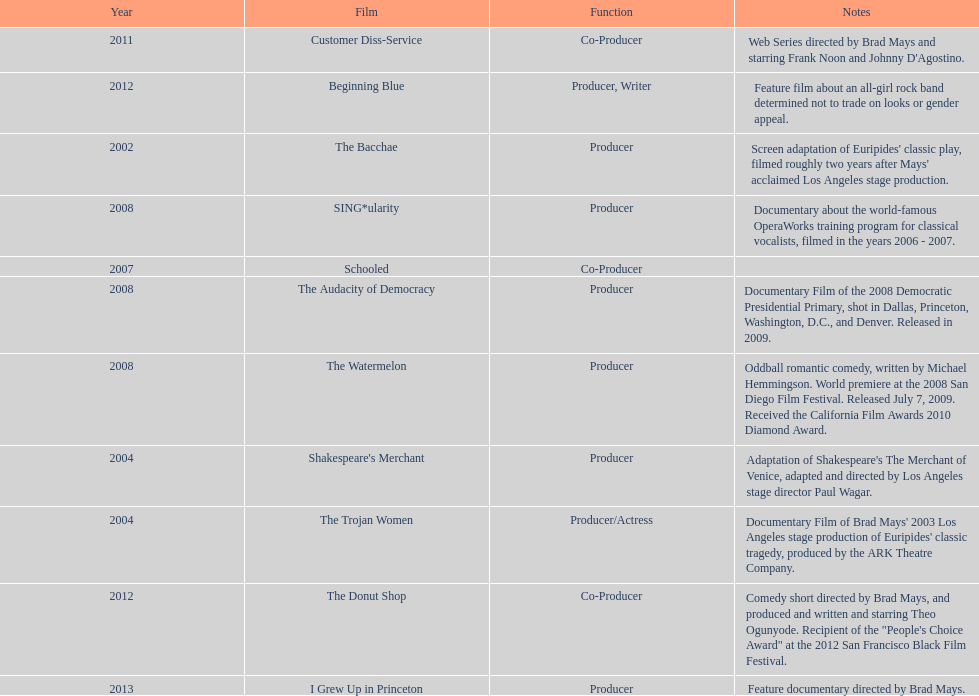Help me parse the entirety of this table. {'header': ['Year', 'Film', 'Function', 'Notes'], 'rows': [['2011', 'Customer Diss-Service', 'Co-Producer', "Web Series directed by Brad Mays and starring Frank Noon and Johnny D'Agostino."], ['2012', 'Beginning Blue', 'Producer, Writer', 'Feature film about an all-girl rock band determined not to trade on looks or gender appeal.'], ['2002', 'The Bacchae', 'Producer', "Screen adaptation of Euripides' classic play, filmed roughly two years after Mays' acclaimed Los Angeles stage production."], ['2008', 'SING*ularity', 'Producer', 'Documentary about the world-famous OperaWorks training program for classical vocalists, filmed in the years 2006 - 2007.'], ['2007', 'Schooled', 'Co-Producer', ''], ['2008', 'The Audacity of Democracy', 'Producer', 'Documentary Film of the 2008 Democratic Presidential Primary, shot in Dallas, Princeton, Washington, D.C., and Denver. Released in 2009.'], ['2008', 'The Watermelon', 'Producer', 'Oddball romantic comedy, written by Michael Hemmingson. World premiere at the 2008 San Diego Film Festival. Released July 7, 2009. Received the California Film Awards 2010 Diamond Award.'], ['2004', "Shakespeare's Merchant", 'Producer', "Adaptation of Shakespeare's The Merchant of Venice, adapted and directed by Los Angeles stage director Paul Wagar."], ['2004', 'The Trojan Women', 'Producer/Actress', "Documentary Film of Brad Mays' 2003 Los Angeles stage production of Euripides' classic tragedy, produced by the ARK Theatre Company."], ['2012', 'The Donut Shop', 'Co-Producer', 'Comedy short directed by Brad Mays, and produced and written and starring Theo Ogunyode. Recipient of the "People\'s Choice Award" at the 2012 San Francisco Black Film Festival.'], ['2013', 'I Grew Up in Princeton', 'Producer', 'Feature documentary directed by Brad Mays.']]} How many years before was the film bacchae out before the watermelon? 6. 